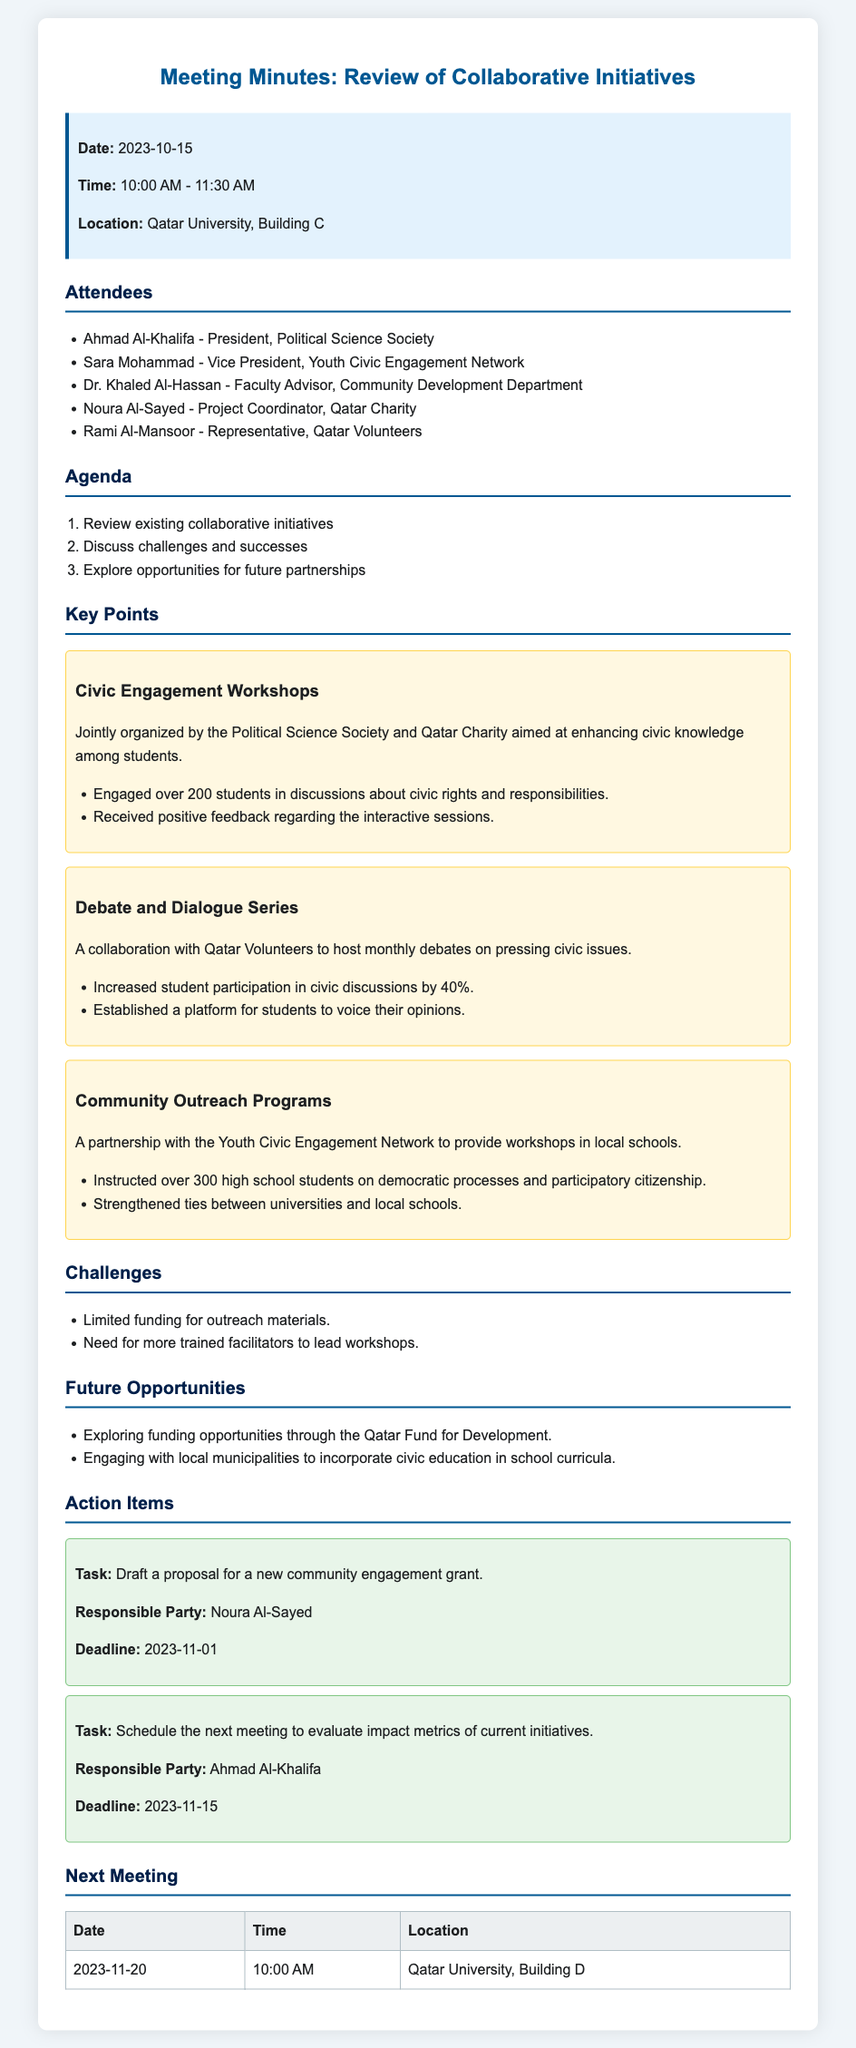what is the date of the meeting? The meeting date mentioned in the minutes is specified at the beginning of the document.
Answer: 2023-10-15 who is the President of the Political Science Society? The meeting minutes list Ahmad Al-Khalifa as the President of the Political Science Society among the attendees.
Answer: Ahmad Al-Khalifa how many students were engaged in the Civic Engagement Workshops? The document states that over 200 students participated in the Civic Engagement Workshops.
Answer: over 200 what is one challenge mentioned in the document? The challenges section lists limited funding for outreach materials as one of the challenges faced.
Answer: Limited funding for outreach materials what is the deadline for the proposal draft assigned to Noura Al-Sayed? The action items outline the deadline for the task assigned to Noura Al-Sayed in the document.
Answer: 2023-11-01 how much did student participation increase in the Debate and Dialogue Series? The minutes specify a 40% increase in student participation due to the series.
Answer: 40% when is the next meeting scheduled? The document includes a table that states the date of the next meeting.
Answer: 2023-11-20 who is responsible for evaluating impact metrics of current initiatives in the next meeting? Ahmad Al-Khalifa is mentioned as the responsible party for scheduling the next meeting to evaluate impact metrics.
Answer: Ahmad Al-Khalifa 